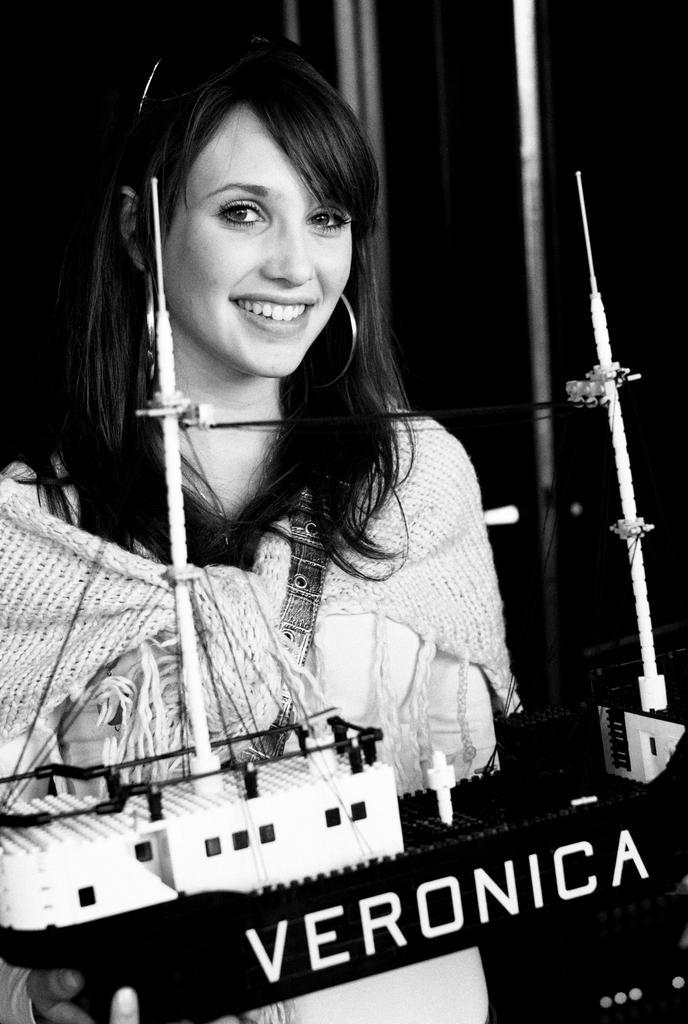Please provide a concise description of this image. In this black and white picture there is a woman standing. She is smiling. She is holding an object in her hand. There is text on that object. It seems to be a model of a ship. Behind her there are metal rods. the background is dark. 